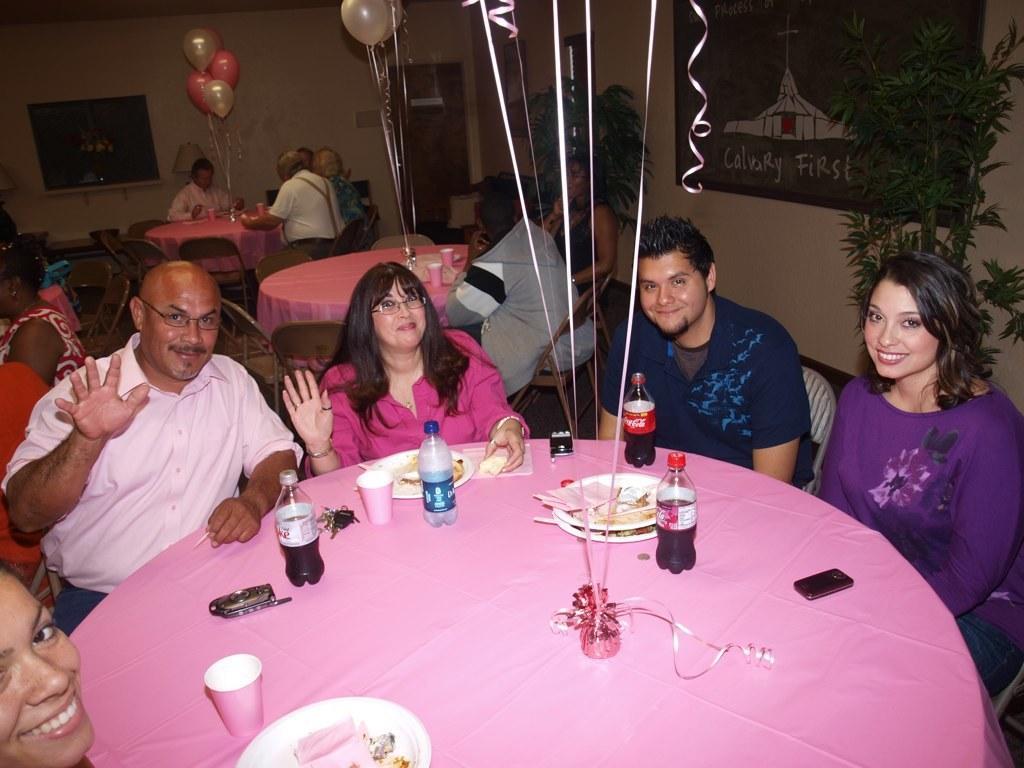Can you describe this image briefly? In this picture we can see a group of people siting on chairs and in front of them on table we have glass, plate with some food items, bottle with drink in it, mobile and they are smiling and in background we can see some more persons, balloons, wall, frame, door, plants. 